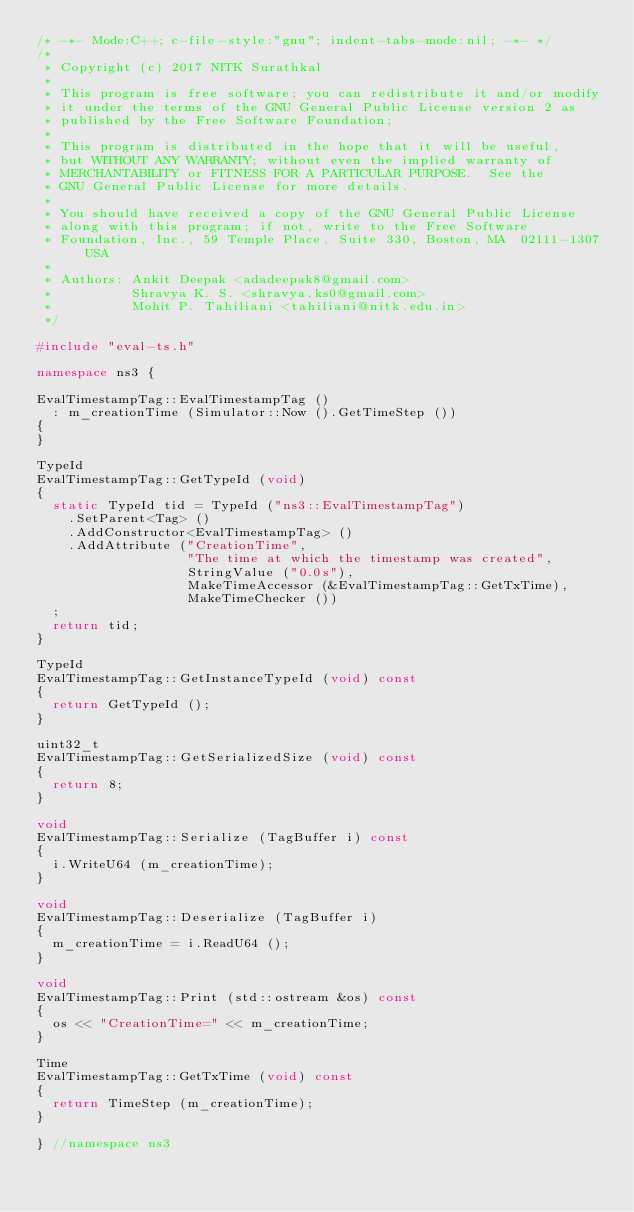<code> <loc_0><loc_0><loc_500><loc_500><_C++_>/* -*- Mode:C++; c-file-style:"gnu"; indent-tabs-mode:nil; -*- */
/*
 * Copyright (c) 2017 NITK Surathkal
 *
 * This program is free software; you can redistribute it and/or modify
 * it under the terms of the GNU General Public License version 2 as
 * published by the Free Software Foundation;
 *
 * This program is distributed in the hope that it will be useful,
 * but WITHOUT ANY WARRANTY; without even the implied warranty of
 * MERCHANTABILITY or FITNESS FOR A PARTICULAR PURPOSE.  See the
 * GNU General Public License for more details.
 *
 * You should have received a copy of the GNU General Public License
 * along with this program; if not, write to the Free Software
 * Foundation, Inc., 59 Temple Place, Suite 330, Boston, MA  02111-1307  USA
 *
 * Authors: Ankit Deepak <adadeepak8@gmail.com>
 *          Shravya K. S. <shravya.ks0@gmail.com>
 *          Mohit P. Tahiliani <tahiliani@nitk.edu.in>
 */

#include "eval-ts.h"

namespace ns3 {

EvalTimestampTag::EvalTimestampTag ()
  : m_creationTime (Simulator::Now ().GetTimeStep ())
{
}

TypeId
EvalTimestampTag::GetTypeId (void)
{
  static TypeId tid = TypeId ("ns3::EvalTimestampTag")
    .SetParent<Tag> ()
    .AddConstructor<EvalTimestampTag> ()
    .AddAttribute ("CreationTime",
                   "The time at which the timestamp was created",
                   StringValue ("0.0s"),
                   MakeTimeAccessor (&EvalTimestampTag::GetTxTime),
                   MakeTimeChecker ())
  ;
  return tid;
}

TypeId
EvalTimestampTag::GetInstanceTypeId (void) const
{
  return GetTypeId ();
}

uint32_t
EvalTimestampTag::GetSerializedSize (void) const
{
  return 8;
}

void
EvalTimestampTag::Serialize (TagBuffer i) const
{
  i.WriteU64 (m_creationTime);
}

void
EvalTimestampTag::Deserialize (TagBuffer i)
{
  m_creationTime = i.ReadU64 ();
}

void
EvalTimestampTag::Print (std::ostream &os) const
{
  os << "CreationTime=" << m_creationTime;
}

Time
EvalTimestampTag::GetTxTime (void) const
{
  return TimeStep (m_creationTime);
}

} //namespace ns3
</code> 